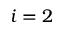<formula> <loc_0><loc_0><loc_500><loc_500>i = 2</formula> 